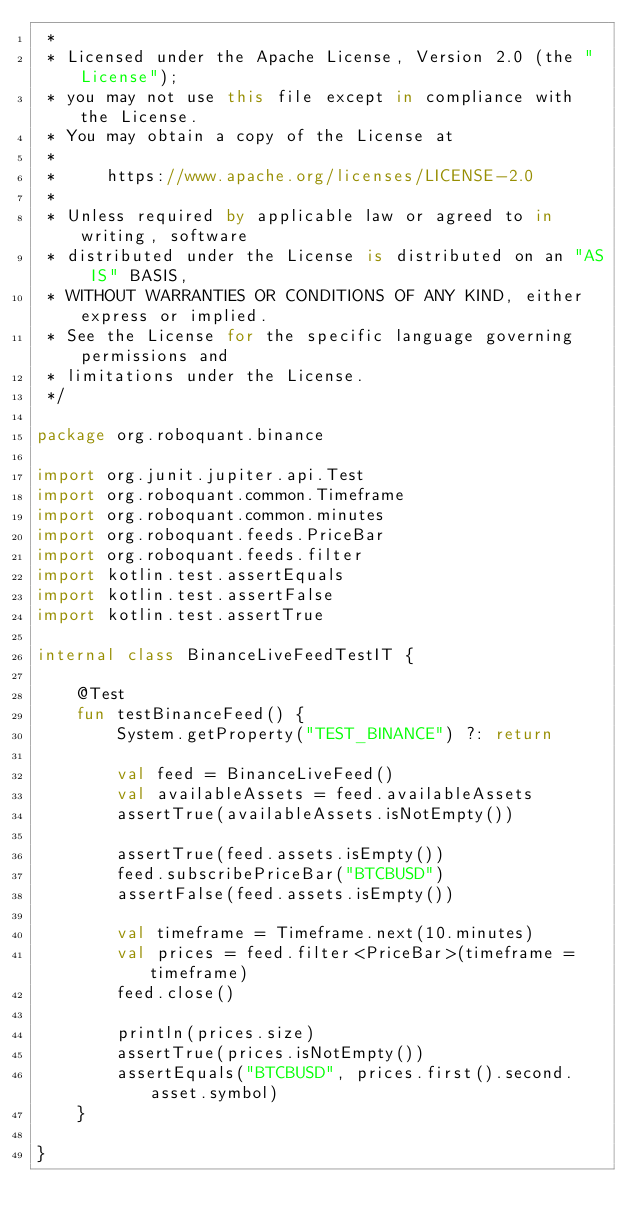<code> <loc_0><loc_0><loc_500><loc_500><_Kotlin_> *
 * Licensed under the Apache License, Version 2.0 (the "License");
 * you may not use this file except in compliance with the License.
 * You may obtain a copy of the License at
 *
 *     https://www.apache.org/licenses/LICENSE-2.0
 *
 * Unless required by applicable law or agreed to in writing, software
 * distributed under the License is distributed on an "AS IS" BASIS,
 * WITHOUT WARRANTIES OR CONDITIONS OF ANY KIND, either express or implied.
 * See the License for the specific language governing permissions and
 * limitations under the License.
 */

package org.roboquant.binance

import org.junit.jupiter.api.Test
import org.roboquant.common.Timeframe
import org.roboquant.common.minutes
import org.roboquant.feeds.PriceBar
import org.roboquant.feeds.filter
import kotlin.test.assertEquals
import kotlin.test.assertFalse
import kotlin.test.assertTrue

internal class BinanceLiveFeedTestIT {

    @Test
    fun testBinanceFeed() {
        System.getProperty("TEST_BINANCE") ?: return

        val feed = BinanceLiveFeed()
        val availableAssets = feed.availableAssets
        assertTrue(availableAssets.isNotEmpty())

        assertTrue(feed.assets.isEmpty())
        feed.subscribePriceBar("BTCBUSD")
        assertFalse(feed.assets.isEmpty())

        val timeframe = Timeframe.next(10.minutes)
        val prices = feed.filter<PriceBar>(timeframe = timeframe)
        feed.close()

        println(prices.size)
        assertTrue(prices.isNotEmpty())
        assertEquals("BTCBUSD", prices.first().second.asset.symbol)
    }

}

</code> 